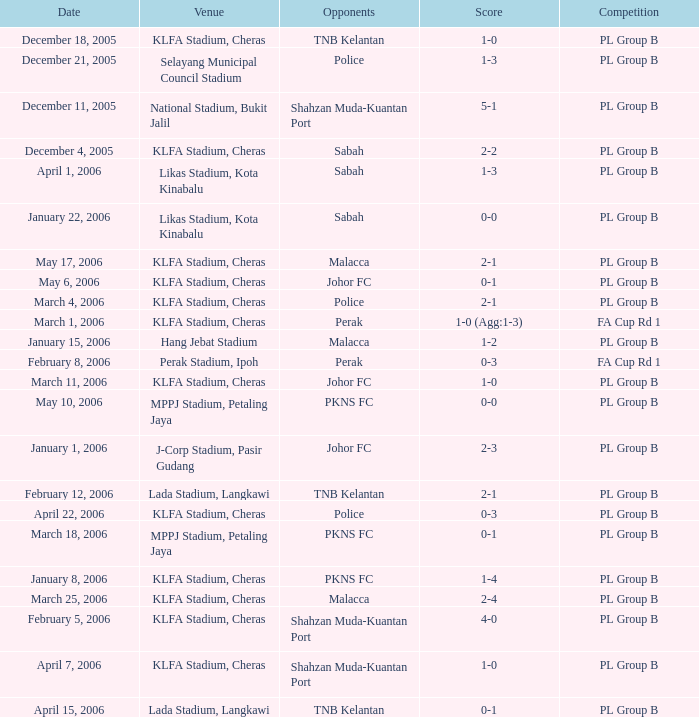What is the score for opponents of pkns fc on january 8, 2006? 1-4. Could you parse the entire table as a dict? {'header': ['Date', 'Venue', 'Opponents', 'Score', 'Competition'], 'rows': [['December 18, 2005', 'KLFA Stadium, Cheras', 'TNB Kelantan', '1-0', 'PL Group B'], ['December 21, 2005', 'Selayang Municipal Council Stadium', 'Police', '1-3', 'PL Group B'], ['December 11, 2005', 'National Stadium, Bukit Jalil', 'Shahzan Muda-Kuantan Port', '5-1', 'PL Group B'], ['December 4, 2005', 'KLFA Stadium, Cheras', 'Sabah', '2-2', 'PL Group B'], ['April 1, 2006', 'Likas Stadium, Kota Kinabalu', 'Sabah', '1-3', 'PL Group B'], ['January 22, 2006', 'Likas Stadium, Kota Kinabalu', 'Sabah', '0-0', 'PL Group B'], ['May 17, 2006', 'KLFA Stadium, Cheras', 'Malacca', '2-1', 'PL Group B'], ['May 6, 2006', 'KLFA Stadium, Cheras', 'Johor FC', '0-1', 'PL Group B'], ['March 4, 2006', 'KLFA Stadium, Cheras', 'Police', '2-1', 'PL Group B'], ['March 1, 2006', 'KLFA Stadium, Cheras', 'Perak', '1-0 (Agg:1-3)', 'FA Cup Rd 1'], ['January 15, 2006', 'Hang Jebat Stadium', 'Malacca', '1-2', 'PL Group B'], ['February 8, 2006', 'Perak Stadium, Ipoh', 'Perak', '0-3', 'FA Cup Rd 1'], ['March 11, 2006', 'KLFA Stadium, Cheras', 'Johor FC', '1-0', 'PL Group B'], ['May 10, 2006', 'MPPJ Stadium, Petaling Jaya', 'PKNS FC', '0-0', 'PL Group B'], ['January 1, 2006', 'J-Corp Stadium, Pasir Gudang', 'Johor FC', '2-3', 'PL Group B'], ['February 12, 2006', 'Lada Stadium, Langkawi', 'TNB Kelantan', '2-1', 'PL Group B'], ['April 22, 2006', 'KLFA Stadium, Cheras', 'Police', '0-3', 'PL Group B'], ['March 18, 2006', 'MPPJ Stadium, Petaling Jaya', 'PKNS FC', '0-1', 'PL Group B'], ['January 8, 2006', 'KLFA Stadium, Cheras', 'PKNS FC', '1-4', 'PL Group B'], ['March 25, 2006', 'KLFA Stadium, Cheras', 'Malacca', '2-4', 'PL Group B'], ['February 5, 2006', 'KLFA Stadium, Cheras', 'Shahzan Muda-Kuantan Port', '4-0', 'PL Group B'], ['April 7, 2006', 'KLFA Stadium, Cheras', 'Shahzan Muda-Kuantan Port', '1-0', 'PL Group B'], ['April 15, 2006', 'Lada Stadium, Langkawi', 'TNB Kelantan', '0-1', 'PL Group B']]} 